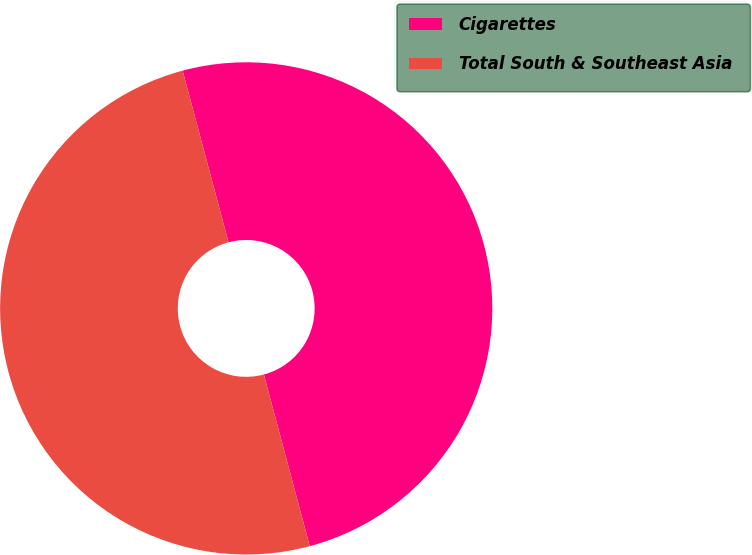Convert chart. <chart><loc_0><loc_0><loc_500><loc_500><pie_chart><fcel>Cigarettes<fcel>Total South & Southeast Asia<nl><fcel>50.0%<fcel>50.0%<nl></chart> 